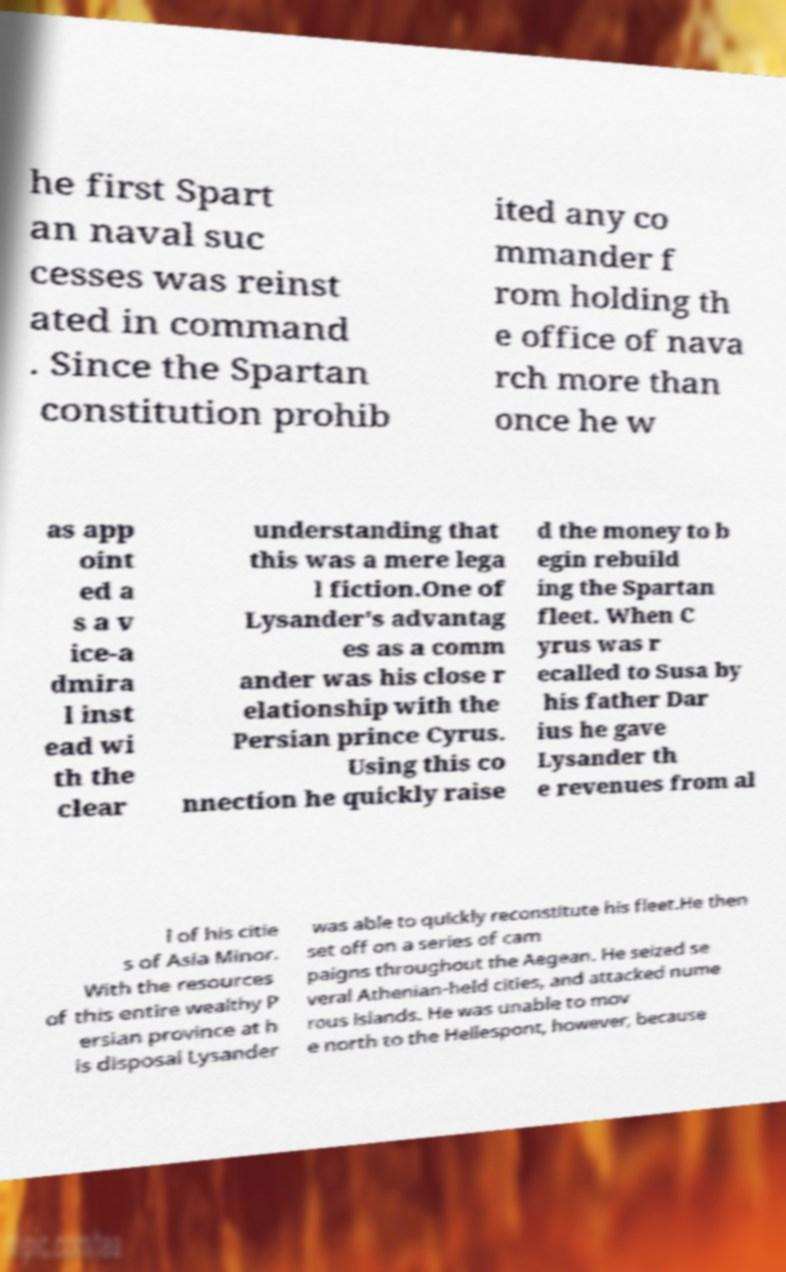Please identify and transcribe the text found in this image. he first Spart an naval suc cesses was reinst ated in command . Since the Spartan constitution prohib ited any co mmander f rom holding th e office of nava rch more than once he w as app oint ed a s a v ice-a dmira l inst ead wi th the clear understanding that this was a mere lega l fiction.One of Lysander's advantag es as a comm ander was his close r elationship with the Persian prince Cyrus. Using this co nnection he quickly raise d the money to b egin rebuild ing the Spartan fleet. When C yrus was r ecalled to Susa by his father Dar ius he gave Lysander th e revenues from al l of his citie s of Asia Minor. With the resources of this entire wealthy P ersian province at h is disposal Lysander was able to quickly reconstitute his fleet.He then set off on a series of cam paigns throughout the Aegean. He seized se veral Athenian-held cities, and attacked nume rous islands. He was unable to mov e north to the Hellespont, however, because 